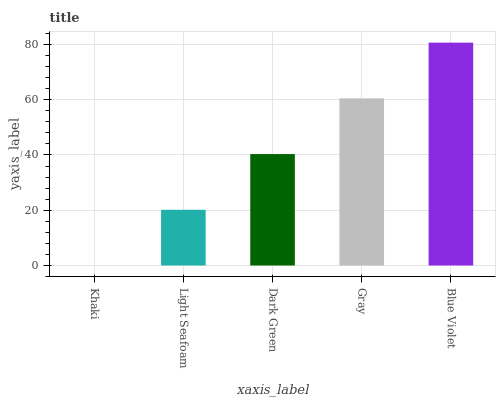Is Khaki the minimum?
Answer yes or no. Yes. Is Blue Violet the maximum?
Answer yes or no. Yes. Is Light Seafoam the minimum?
Answer yes or no. No. Is Light Seafoam the maximum?
Answer yes or no. No. Is Light Seafoam greater than Khaki?
Answer yes or no. Yes. Is Khaki less than Light Seafoam?
Answer yes or no. Yes. Is Khaki greater than Light Seafoam?
Answer yes or no. No. Is Light Seafoam less than Khaki?
Answer yes or no. No. Is Dark Green the high median?
Answer yes or no. Yes. Is Dark Green the low median?
Answer yes or no. Yes. Is Khaki the high median?
Answer yes or no. No. Is Gray the low median?
Answer yes or no. No. 